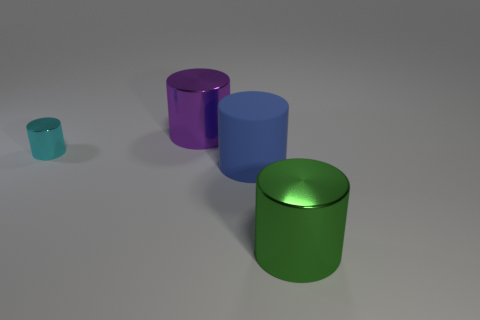Add 2 large purple metal blocks. How many objects exist? 6 Subtract 1 purple cylinders. How many objects are left? 3 Subtract all large green cylinders. Subtract all purple cylinders. How many objects are left? 2 Add 1 blue things. How many blue things are left? 2 Add 3 blue balls. How many blue balls exist? 3 